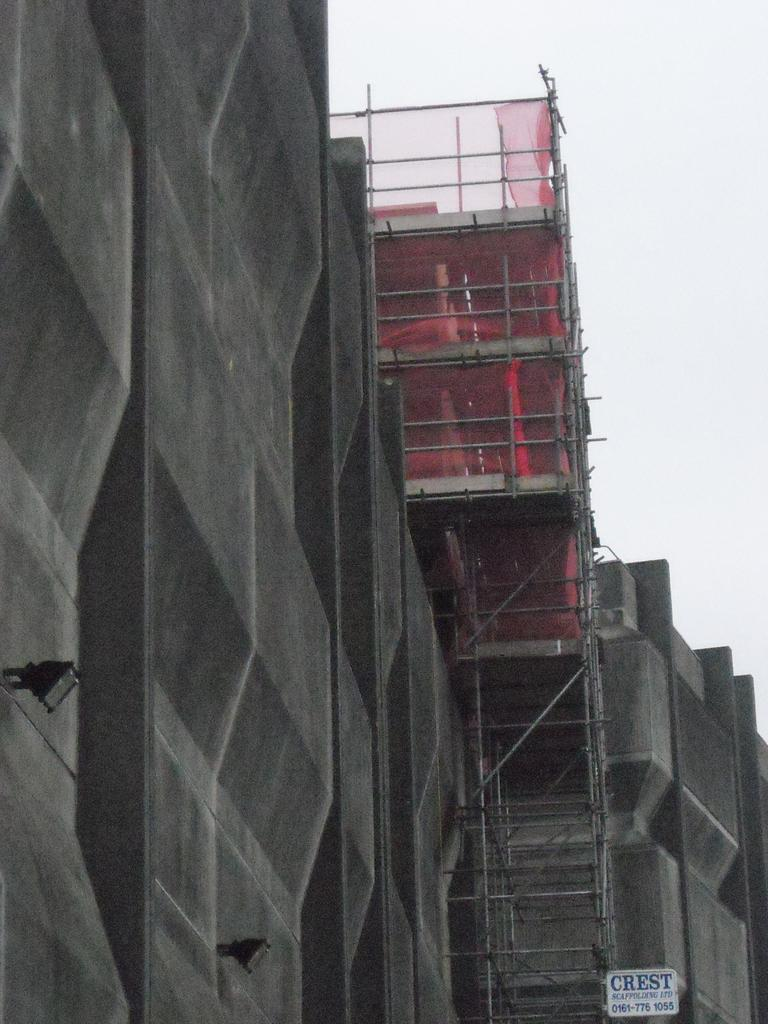What type of structures are visible in the image? There are under-constructed buildings in the image. What can be seen on the buildings? Poles are present on the buildings. What else is visible on the buildings? There is a net on the buildings. What type of grape is being used to decorate the cake in the image? There is no cake or grape present in the image; it features under-constructed buildings with poles and a net. 